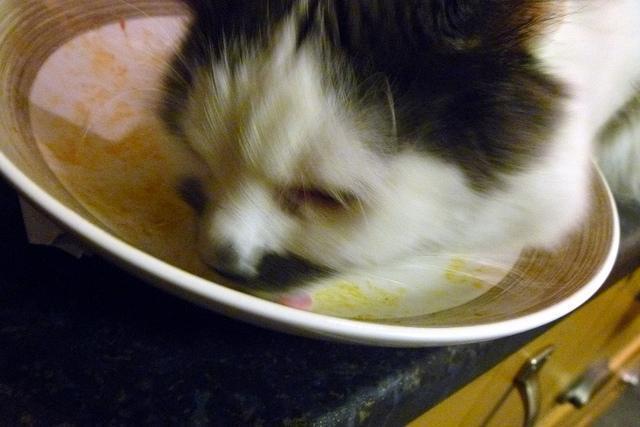How many train cars are visible?
Give a very brief answer. 0. 